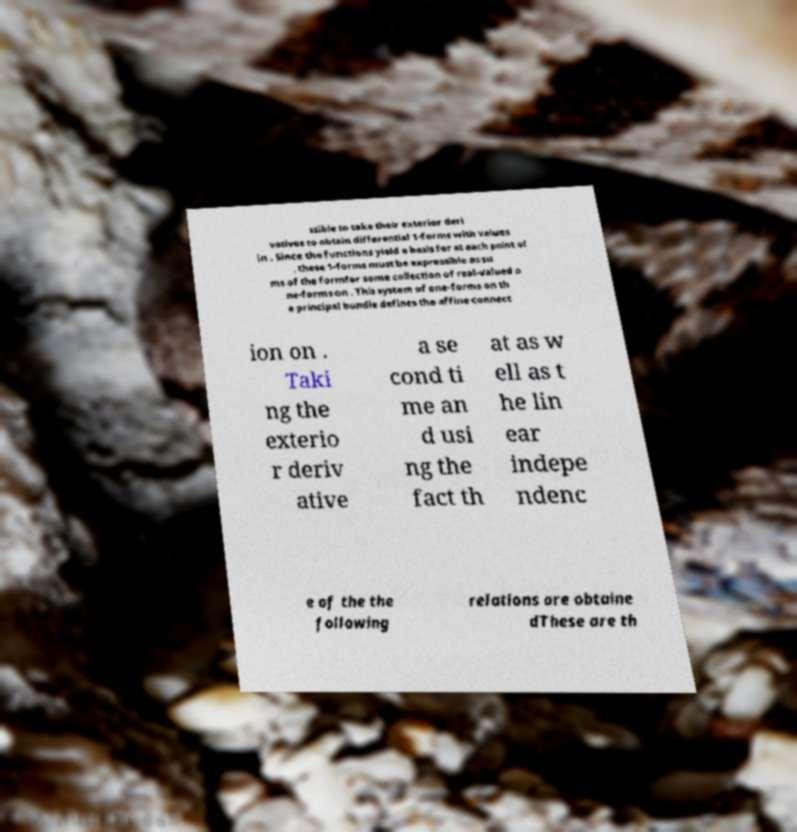Could you extract and type out the text from this image? ssible to take their exterior deri vatives to obtain differential 1-forms with values in . Since the functions yield a basis for at each point of , these 1-forms must be expressible as su ms of the formfor some collection of real-valued o ne-forms on . This system of one-forms on th e principal bundle defines the affine connect ion on . Taki ng the exterio r deriv ative a se cond ti me an d usi ng the fact th at as w ell as t he lin ear indepe ndenc e of the the following relations are obtaine dThese are th 